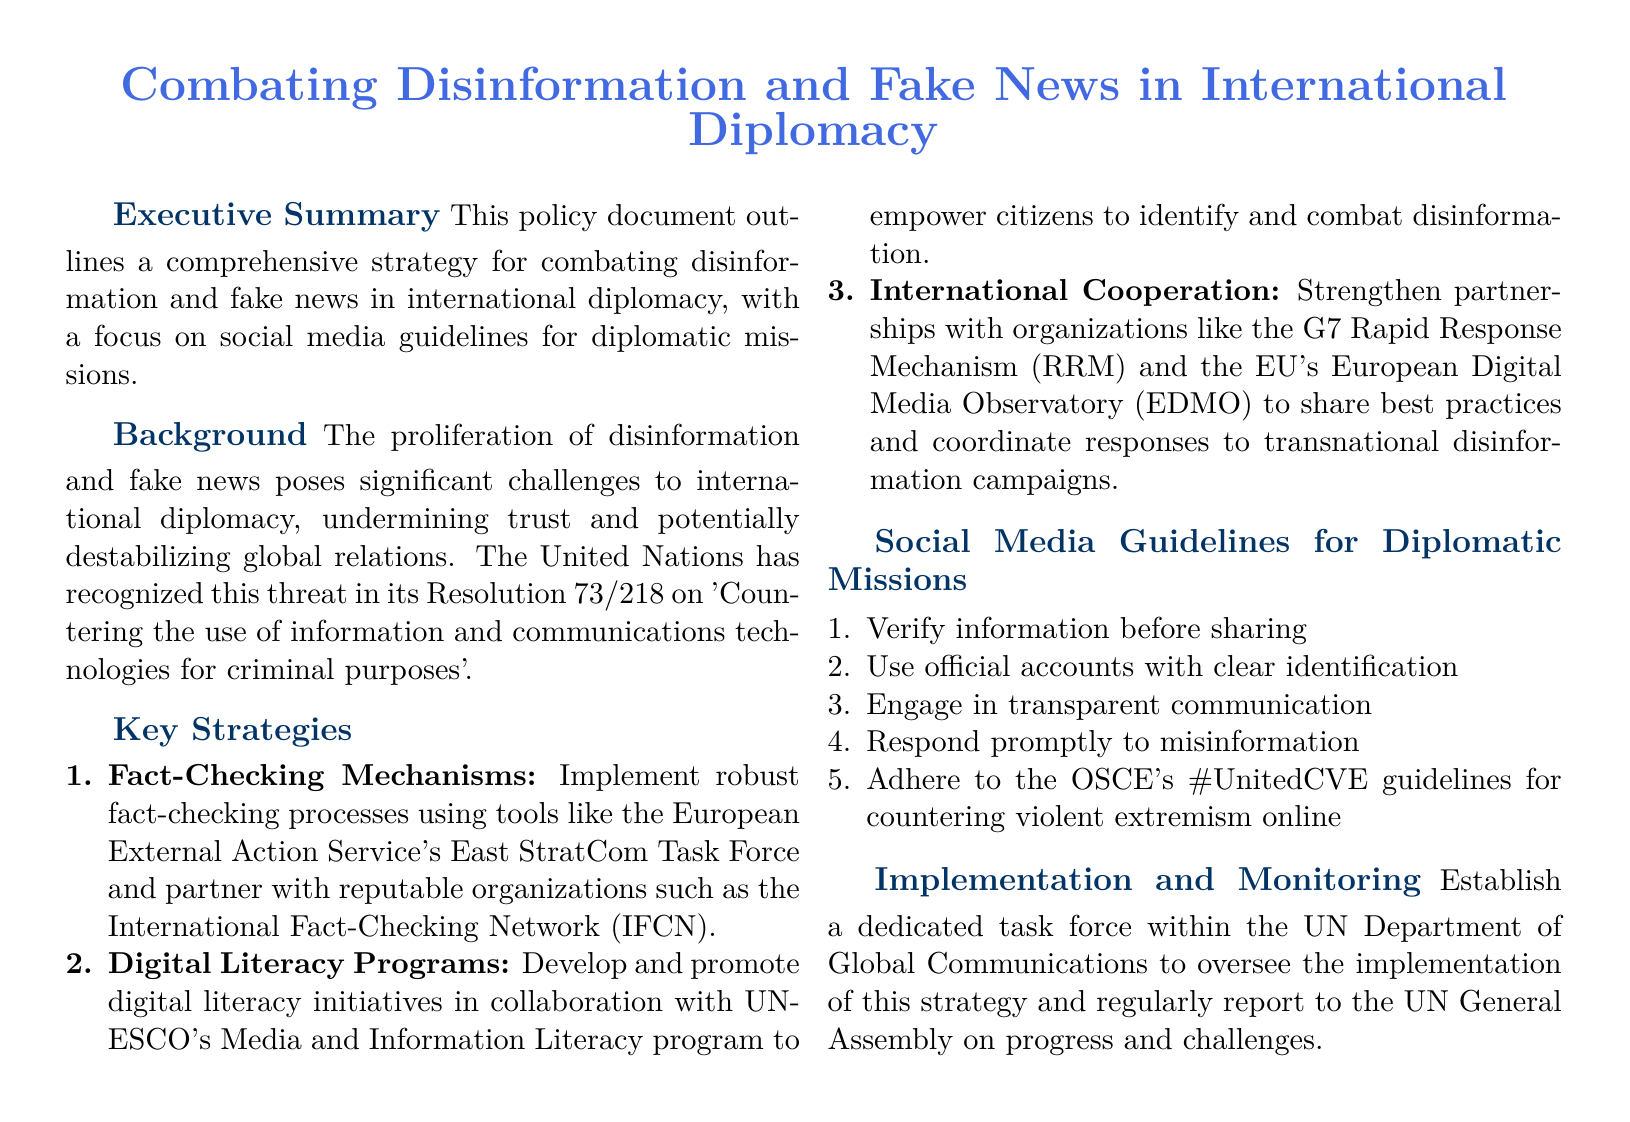What is the title of the document? The title provides an overview of the document's purpose and focus.
Answer: Combating Disinformation and Fake News in International Diplomacy What is Resolution 73/218 about? The document mentions the resolution in relation to the threat of disinformation and fake news.
Answer: Countering the use of information and communications technologies for criminal purposes Who is the partner organization for fact-checking processes? The document specifies a key partner in implementing fact-checking mechanisms.
Answer: International Fact-Checking Network (IFCN) What is the focus of the digital literacy programs? This question connects the strategy with its intended impact on the public.
Answer: Empower citizens to identify and combat disinformation How many key strategies are outlined in the document? The number indicates the breadth of the strategies proposed for implementation.
Answer: 3 What acronym is associated with the countering violent extremism guidelines? The document mentions this specific set of guidelines designed for social media use.
Answer: OSCE's #UnitedCVE What body will oversee the implementation of the strategy? Identifying who is responsible for monitoring the strategy's effectiveness.
Answer: UN Department of Global Communications What is the primary goal of implementing robust fact-checking processes? Understanding the ultimate aim of the strategy concerning disinformation.
Answer: Combat disinformation Which organization is mentioned in relation to international cooperation against disinformation? This question highlights a vital partnership within the proposed strategies.
Answer: G7 Rapid Response Mechanism (RRM) 